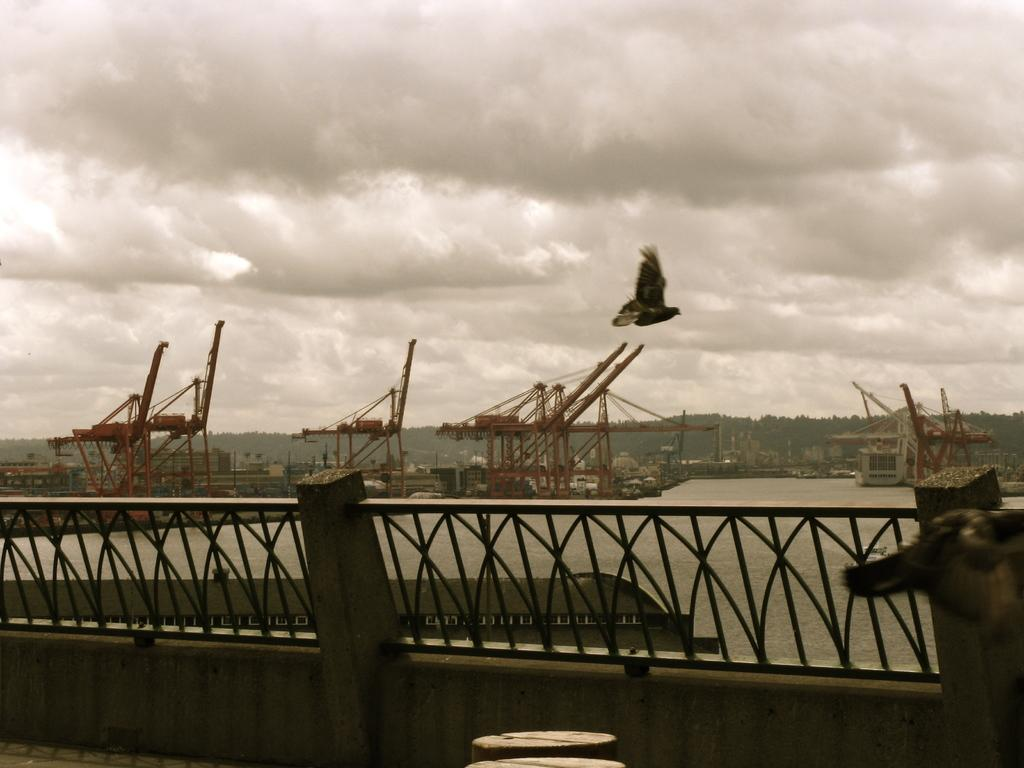What type of natural feature can be seen in the image? There is a river in the image. What man-made structure is present in the image? There is a fence in the image. What can be seen in the background of the image? There are many trees in the background of the image. What type of animal is visible in the image? There is a bird in the image. What part of the sky is visible in the image? The sky is visible in the image. How would you describe the clouds in the sky? The clouds in the sky appear heavy. How many pins are holding the son's drawing on the fridge in the image? There is no son or drawing on a fridge present in the image. Can you describe the type of kiss the bird is giving to the tree in the image? There is no kiss present in the image; it features a bird and a tree, but no interaction between them. 